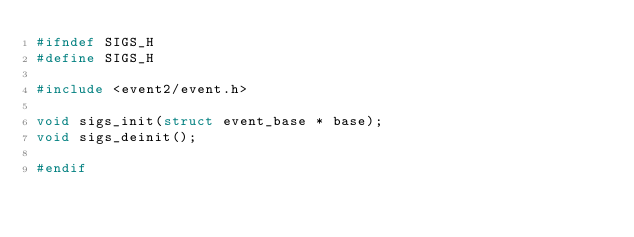Convert code to text. <code><loc_0><loc_0><loc_500><loc_500><_C_>#ifndef SIGS_H
#define SIGS_H

#include <event2/event.h>

void sigs_init(struct event_base * base);
void sigs_deinit();

#endif
</code> 